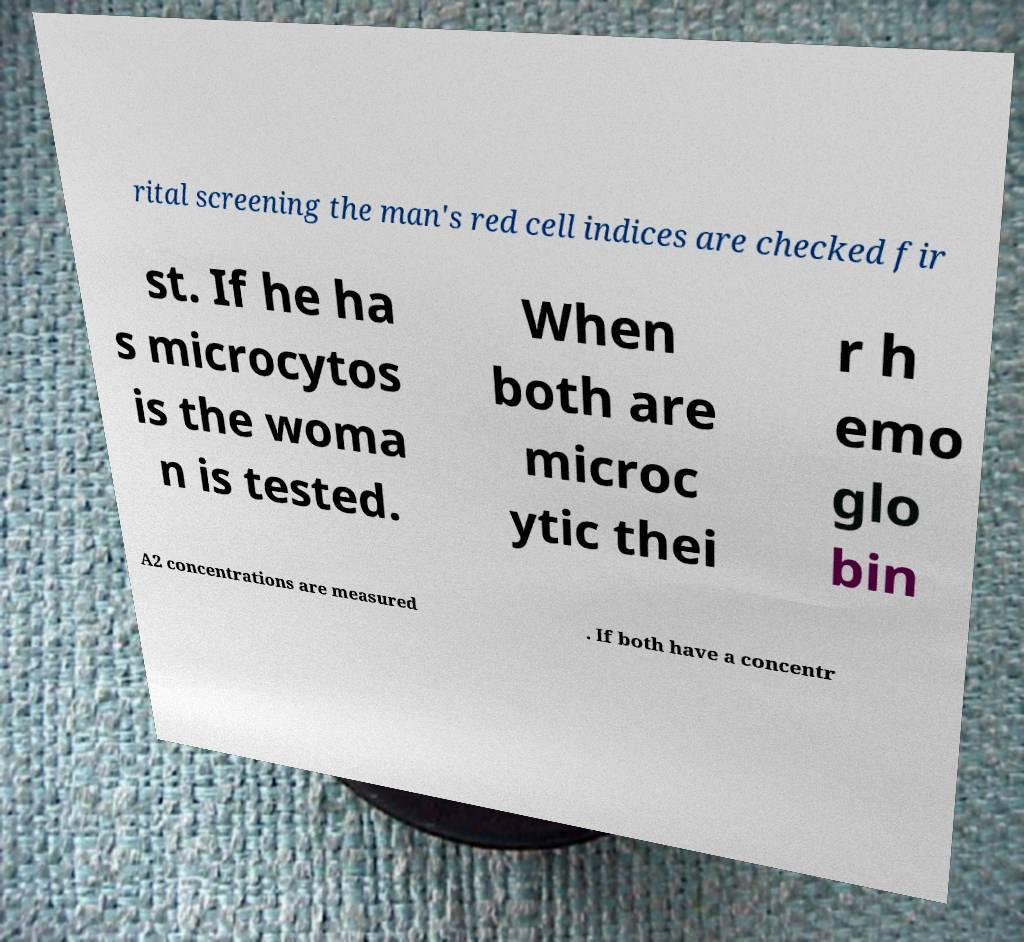I need the written content from this picture converted into text. Can you do that? rital screening the man's red cell indices are checked fir st. If he ha s microcytos is the woma n is tested. When both are microc ytic thei r h emo glo bin A2 concentrations are measured . If both have a concentr 